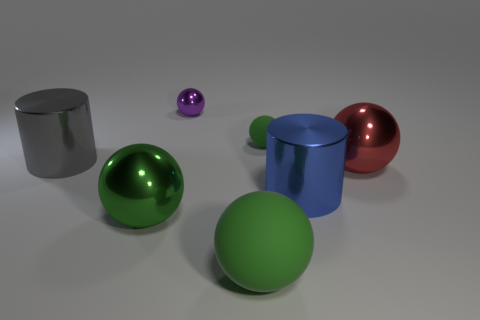What is the shape of the metallic thing that is the same color as the small matte object?
Give a very brief answer. Sphere. Are there any red things of the same shape as the purple shiny thing?
Keep it short and to the point. Yes. There is a shiny ball that is the same size as the green metal object; what color is it?
Your response must be concise. Red. The metallic cylinder on the left side of the green matte sphere that is behind the large blue metal cylinder is what color?
Make the answer very short. Gray. There is a cylinder that is behind the big blue shiny cylinder; is its color the same as the large matte object?
Your answer should be very brief. No. What is the shape of the green matte object that is behind the metal sphere that is in front of the large cylinder right of the large gray cylinder?
Make the answer very short. Sphere. How many large green rubber balls are on the left side of the purple metal sphere left of the red ball?
Your answer should be very brief. 0. Do the big red object and the blue object have the same material?
Give a very brief answer. Yes. There is a green rubber sphere behind the large metallic cylinder left of the tiny green rubber thing; how many red objects are on the left side of it?
Your answer should be compact. 0. There is a big cylinder that is behind the red metal object; what is its color?
Provide a succinct answer. Gray. 